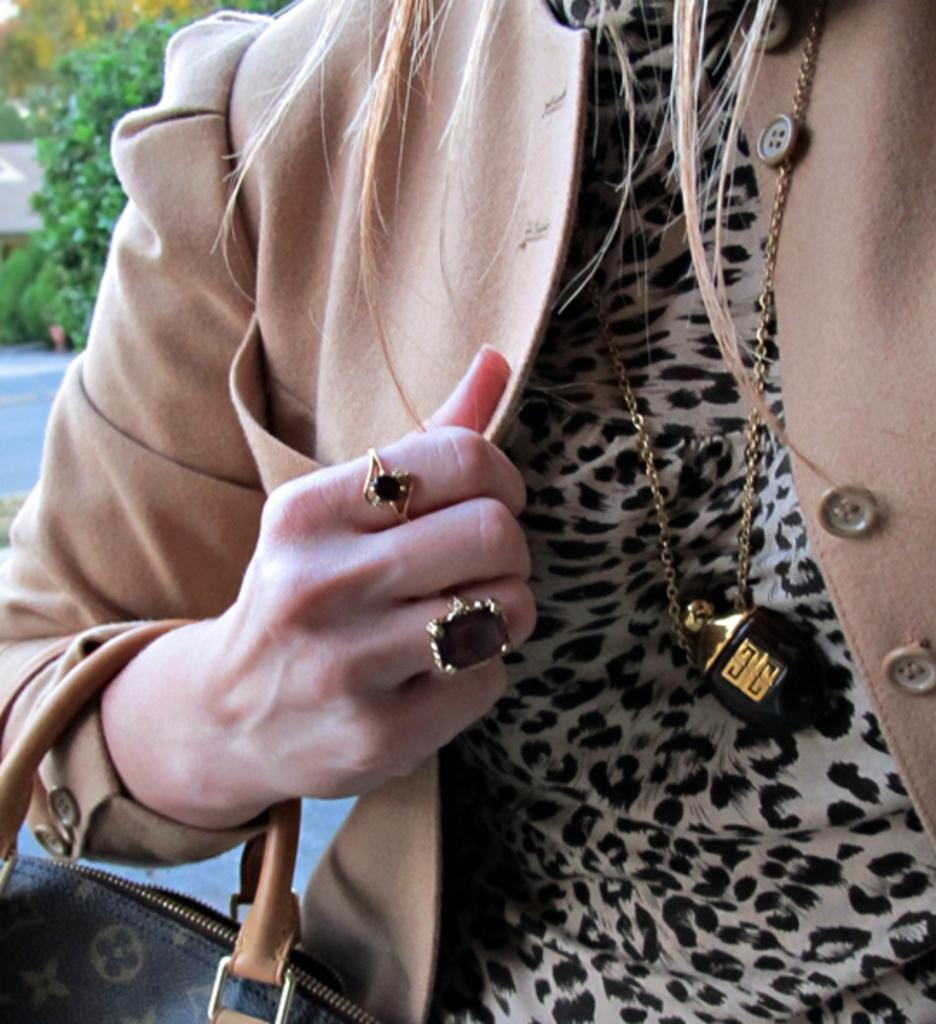What type of jewelry is the woman wearing around her neck? The woman is wearing a dollar with a chain. What type of clothing is the woman wearing? The woman is wearing a suit. What type of jewelry is the woman wearing on her fingers? The woman is wearing rings. What accessory is the woman holding in her hand? The woman is holding a handbag. What can be seen in the background of the image? There are trees in the distance. What is the tendency of the goose in the image? There is no goose present in the image, so it is not possible to determine its tendency. 